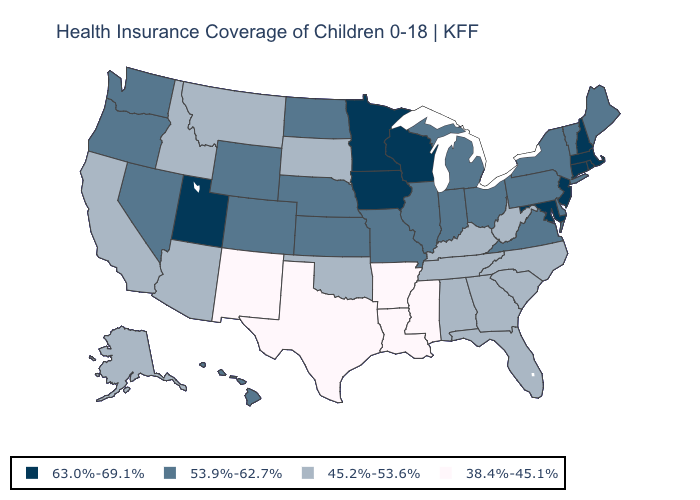Name the states that have a value in the range 63.0%-69.1%?
Be succinct. Connecticut, Iowa, Maryland, Massachusetts, Minnesota, New Hampshire, New Jersey, Rhode Island, Utah, Wisconsin. What is the value of Illinois?
Give a very brief answer. 53.9%-62.7%. Does Colorado have a higher value than Tennessee?
Keep it brief. Yes. Name the states that have a value in the range 45.2%-53.6%?
Short answer required. Alabama, Alaska, Arizona, California, Florida, Georgia, Idaho, Kentucky, Montana, North Carolina, Oklahoma, South Carolina, South Dakota, Tennessee, West Virginia. What is the highest value in states that border Florida?
Give a very brief answer. 45.2%-53.6%. Does Louisiana have the lowest value in the USA?
Keep it brief. Yes. Does the first symbol in the legend represent the smallest category?
Give a very brief answer. No. What is the value of Delaware?
Answer briefly. 53.9%-62.7%. What is the lowest value in the USA?
Quick response, please. 38.4%-45.1%. Which states have the lowest value in the Northeast?
Short answer required. Maine, New York, Pennsylvania, Vermont. What is the value of Ohio?
Quick response, please. 53.9%-62.7%. Name the states that have a value in the range 53.9%-62.7%?
Answer briefly. Colorado, Delaware, Hawaii, Illinois, Indiana, Kansas, Maine, Michigan, Missouri, Nebraska, Nevada, New York, North Dakota, Ohio, Oregon, Pennsylvania, Vermont, Virginia, Washington, Wyoming. Which states have the lowest value in the USA?
Concise answer only. Arkansas, Louisiana, Mississippi, New Mexico, Texas. What is the highest value in the Northeast ?
Write a very short answer. 63.0%-69.1%. Does Maryland have the highest value in the South?
Quick response, please. Yes. 